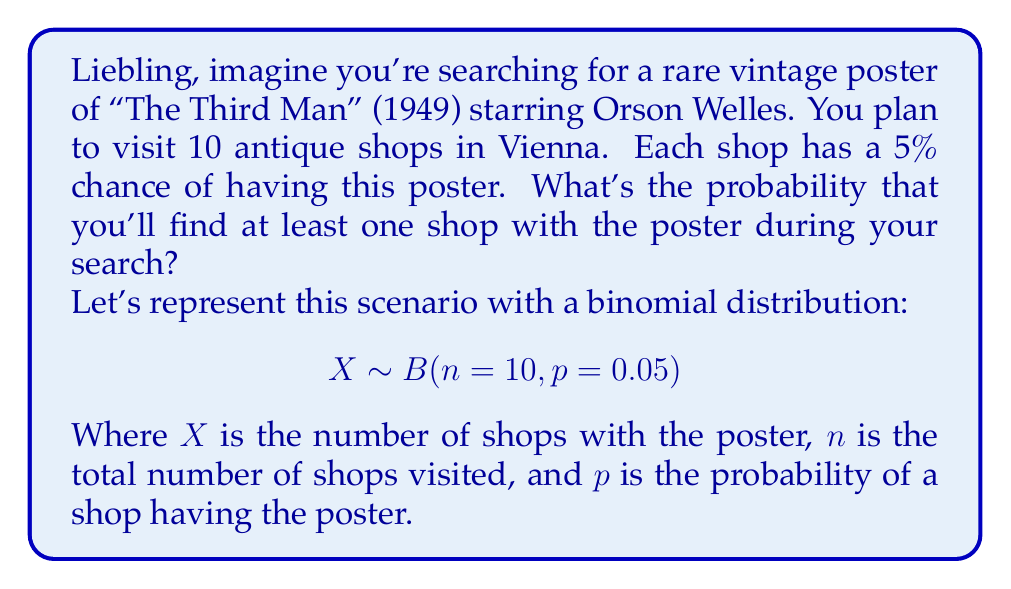Provide a solution to this math problem. To solve this, let's follow these steps:

1) We want to find the probability of finding at least one shop with the poster. This is equivalent to 1 minus the probability of finding no shops with the poster.

2) The probability of finding no shops with the poster:
   $$P(X=0) = \binom{10}{0} (0.05)^0 (0.95)^{10}$$

3) Using the binomial probability formula:
   $$P(X=0) = 1 \cdot 1 \cdot 0.95^{10} = 0.95^{10}$$

4) Calculate:
   $$0.95^{10} \approx 0.5987$$

5) Therefore, the probability of finding at least one shop with the poster is:
   $$P(X \geq 1) = 1 - P(X=0) = 1 - 0.5987 \approx 0.4013$$

6) Convert to percentage:
   $$0.4013 \cdot 100\% \approx 40.13\%$$
Answer: 40.13% 